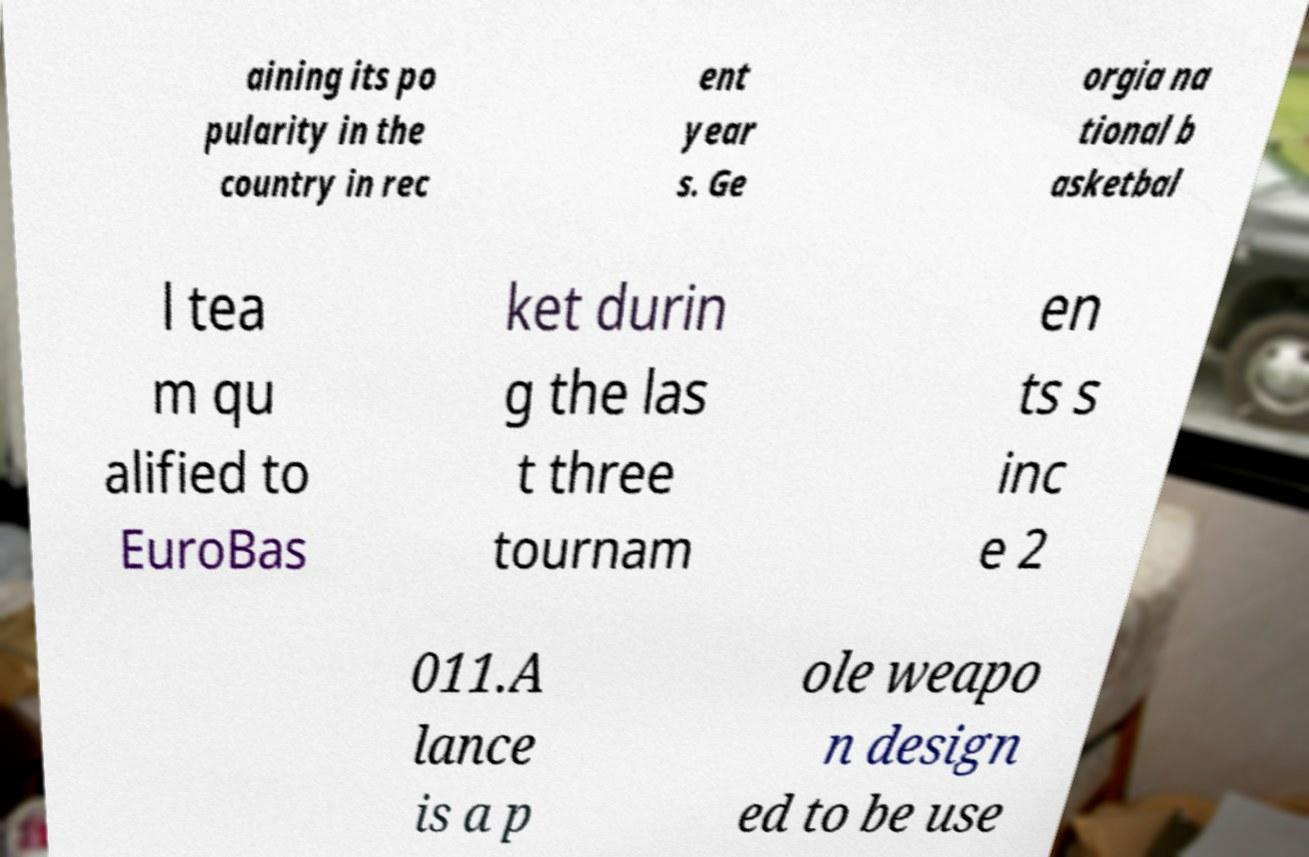Please read and relay the text visible in this image. What does it say? aining its po pularity in the country in rec ent year s. Ge orgia na tional b asketbal l tea m qu alified to EuroBas ket durin g the las t three tournam en ts s inc e 2 011.A lance is a p ole weapo n design ed to be use 